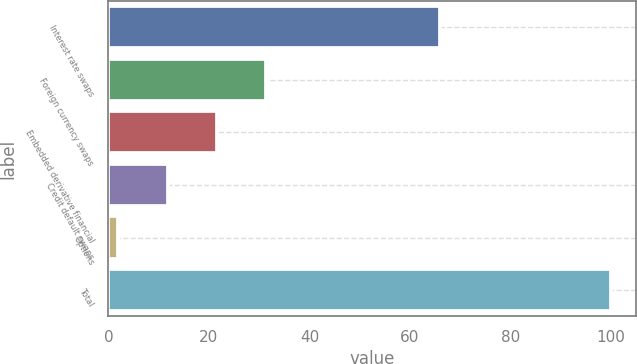<chart> <loc_0><loc_0><loc_500><loc_500><bar_chart><fcel>Interest rate swaps<fcel>Foreign currency swaps<fcel>Embedded derivative financial<fcel>Credit default swaps<fcel>Options<fcel>Total<nl><fcel>66<fcel>31.4<fcel>21.6<fcel>11.8<fcel>2<fcel>100<nl></chart> 